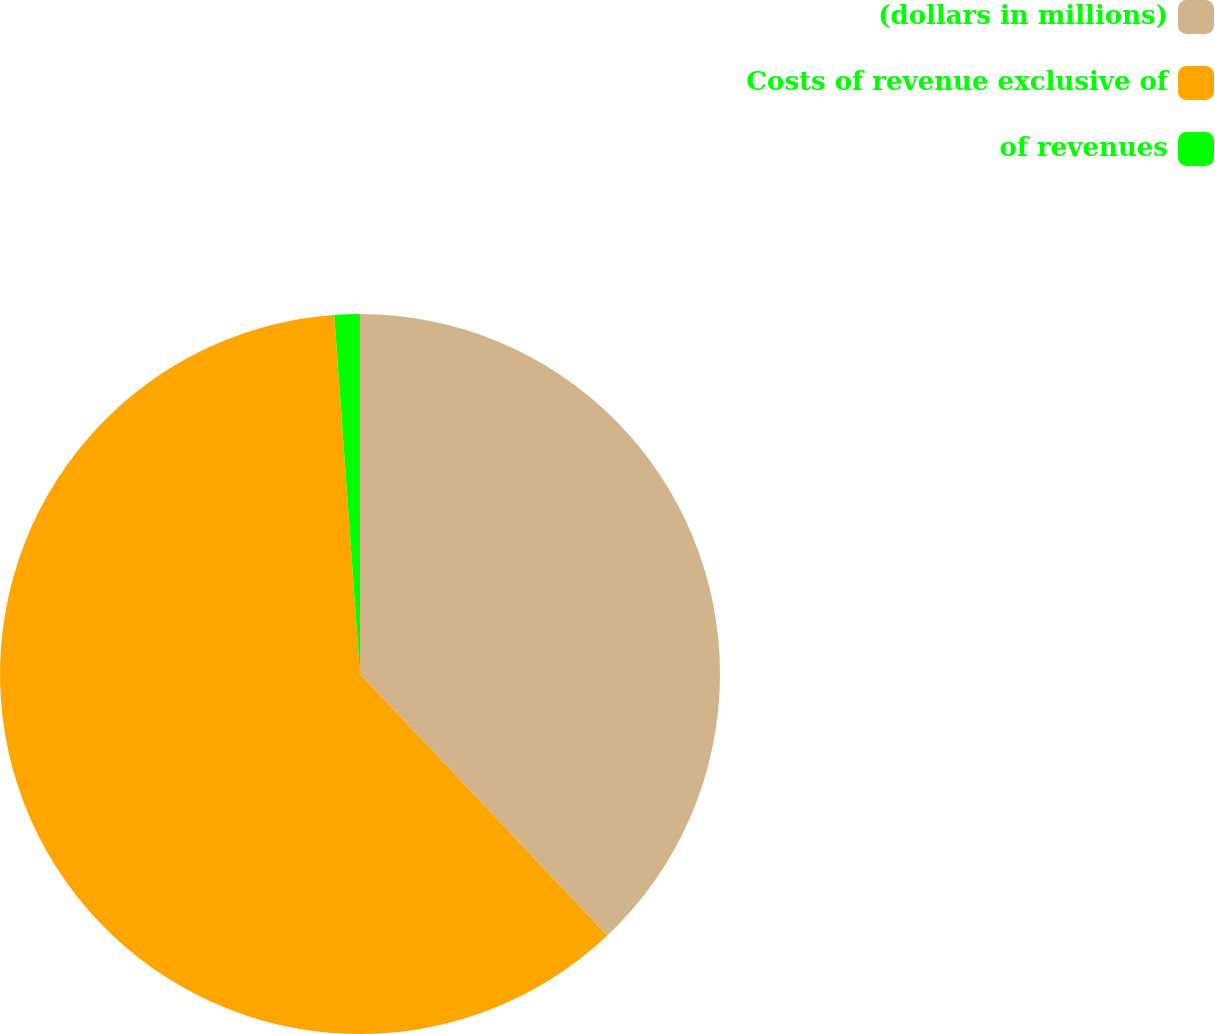<chart> <loc_0><loc_0><loc_500><loc_500><pie_chart><fcel>(dollars in millions)<fcel>Costs of revenue exclusive of<fcel>of revenues<nl><fcel>37.95%<fcel>60.92%<fcel>1.14%<nl></chart> 